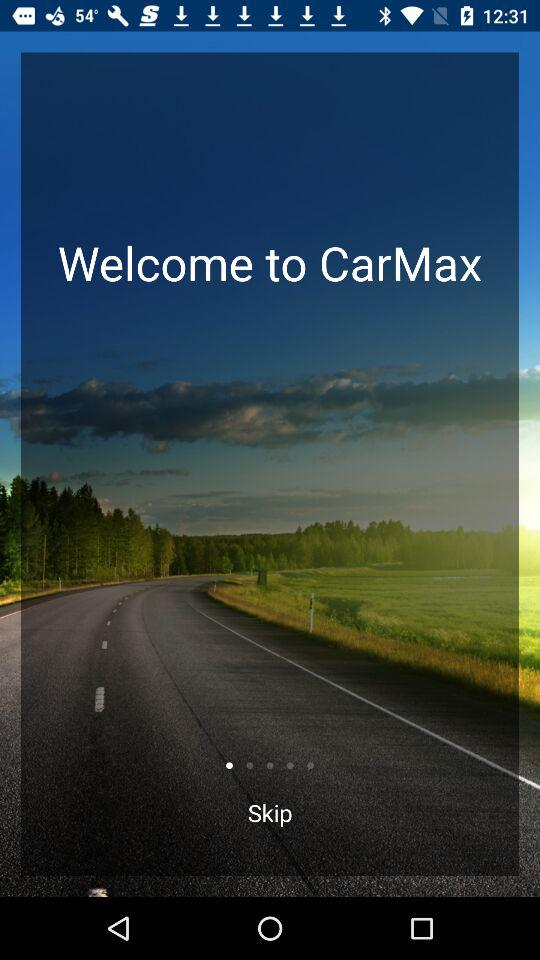What is the app name? The app name is "CarMax". 